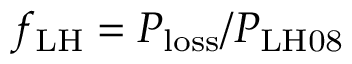Convert formula to latex. <formula><loc_0><loc_0><loc_500><loc_500>f _ { L H } = P _ { l o s s } / P _ { L H 0 8 }</formula> 